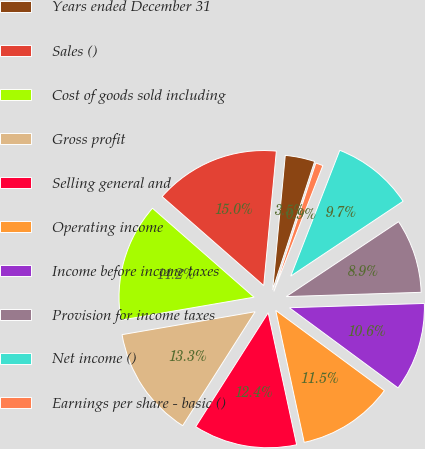<chart> <loc_0><loc_0><loc_500><loc_500><pie_chart><fcel>Years ended December 31<fcel>Sales ()<fcel>Cost of goods sold including<fcel>Gross profit<fcel>Selling general and<fcel>Operating income<fcel>Income before income taxes<fcel>Provision for income taxes<fcel>Net income ()<fcel>Earnings per share - basic ()<nl><fcel>3.54%<fcel>15.04%<fcel>14.16%<fcel>13.27%<fcel>12.39%<fcel>11.5%<fcel>10.62%<fcel>8.85%<fcel>9.73%<fcel>0.88%<nl></chart> 